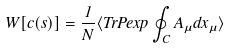<formula> <loc_0><loc_0><loc_500><loc_500>W [ c ( s ) ] = \frac { 1 } { N } \langle T r P e x p \oint _ { C } A _ { \mu } d x _ { \mu } \rangle</formula> 